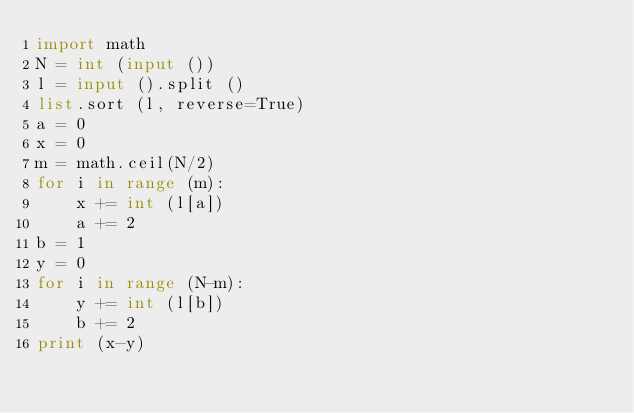Convert code to text. <code><loc_0><loc_0><loc_500><loc_500><_Python_>import math
N = int (input ())
l = input ().split ()
list.sort (l, reverse=True)
a = 0
x = 0
m = math.ceil(N/2)
for i in range (m):
    x += int (l[a])
    a += 2
b = 1
y = 0
for i in range (N-m):
    y += int (l[b])
    b += 2
print (x-y)</code> 